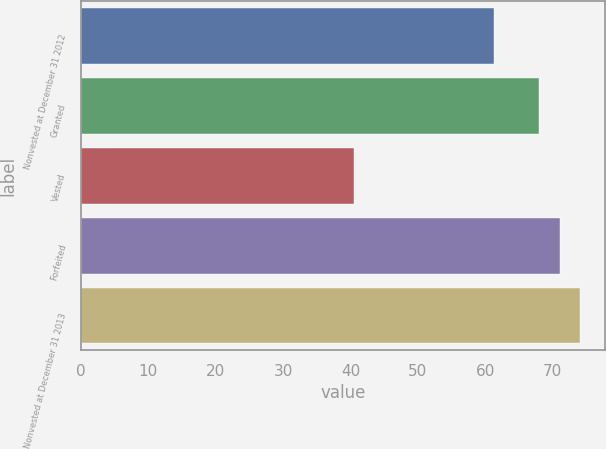Convert chart. <chart><loc_0><loc_0><loc_500><loc_500><bar_chart><fcel>Nonvested at December 31 2012<fcel>Granted<fcel>Vested<fcel>Forfeited<fcel>Nonvested at December 31 2013<nl><fcel>61.23<fcel>67.99<fcel>40.46<fcel>71.05<fcel>74.11<nl></chart> 